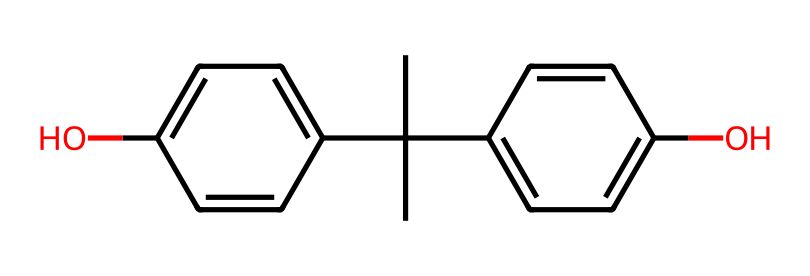How many carbon atoms are in bisphenol A? By analyzing the SMILES representation, we can count the number of carbon atoms present in the structure. The SMILES shows a series of carbon atoms connected with single and double bonds. There are a total of 15 carbon atoms identified in the structure.
Answer: 15 What functional groups are present in bisphenol A? By interpreting the SMILES structure, we notice hydroxyl groups (-OH) attached to the aromatic rings. The presence of these hydroxyl groups indicates that bisphenol A contains phenolic functional groups.
Answer: phenolic How many hydroxyl groups are present in bisphenol A? Observing the structure, we can see two distinct positions where hydroxyl (-OH) groups are attached to the aromatic rings in the structure. Thus, we can confirm the presence of two hydroxyl groups in bisphenol A.
Answer: 2 What type of chemical is bisphenol A classified as? The structural features evident in the SMILES represent indicating the presence of aromatic rings and hydroxyl groups suggest that bisphenol A is classified as a phenol derivative, often categorized under endocrine-disrupting chemicals.
Answer: phenol What is the molecular formula of bisphenol A? To determine the molecular formula, we interpret the SMILES representation to count each type of atom. After counting, we find the molecular formula to be C15H16O2, derived directly from the carbon, hydrogen, and oxygen counts in the structure.
Answer: C15H16O2 Is bisphenol A a hazardous chemical? Based on numerous studies, bisphenol A is recognized as potentially hazardous due to its endocrine-disrupting effects, making it concerning in contexts such as plastic packaging and water bottles.
Answer: yes 